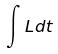Convert formula to latex. <formula><loc_0><loc_0><loc_500><loc_500>\int L d t</formula> 